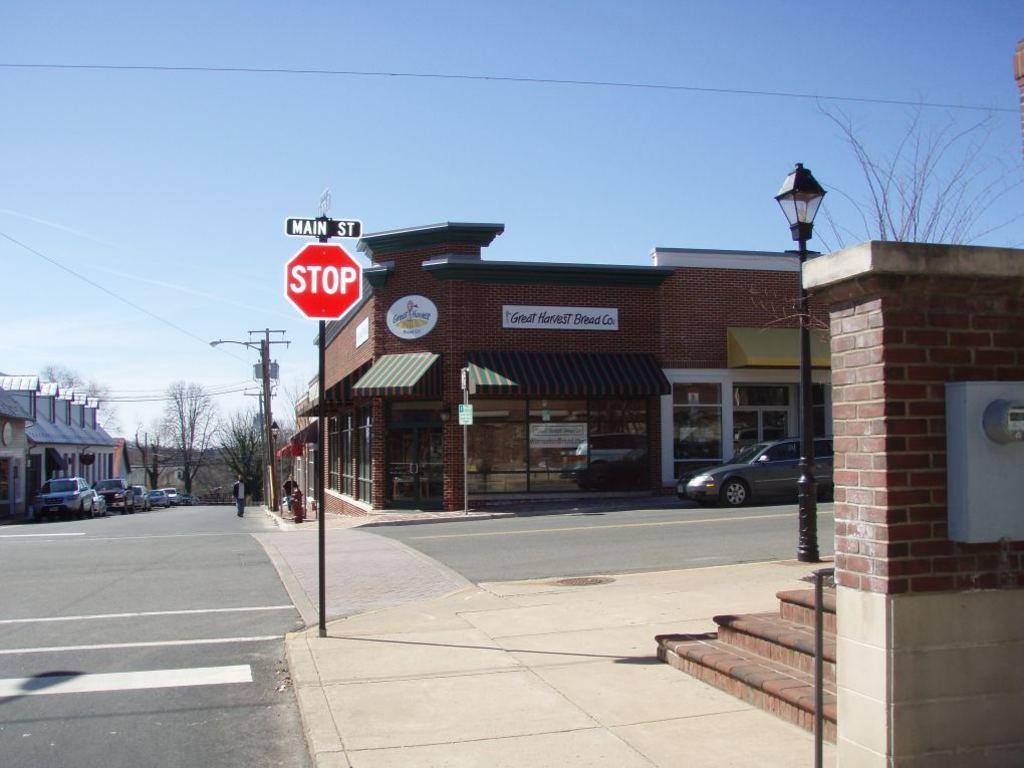Can you describe this image briefly? This picture is clicked outside the city. On the right side, we see the staircase, wall, streetlight and a tree. In the middle of the picture, we see a pole and a board in red color with text written as "STOP". At the bottom, we see the road. There are buildings, trees and street lights in the background. We even see the cars parked on the road. The man in black jacket is walking on the road. At the top, we see the sky and the wires. 